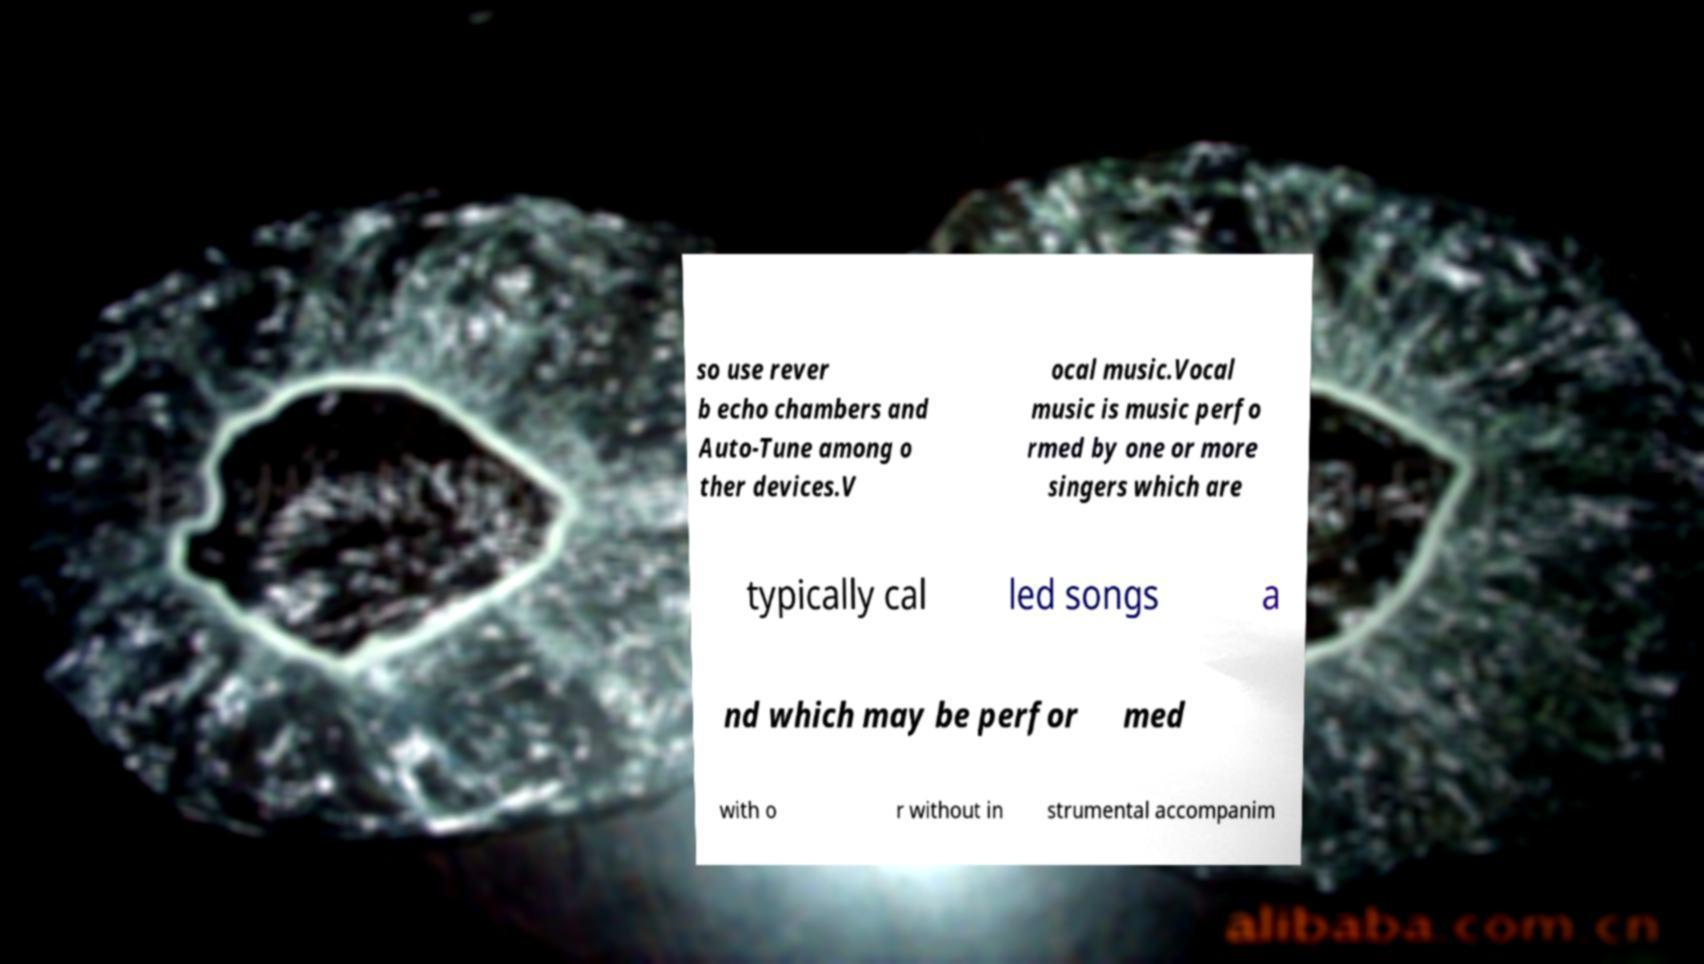There's text embedded in this image that I need extracted. Can you transcribe it verbatim? so use rever b echo chambers and Auto-Tune among o ther devices.V ocal music.Vocal music is music perfo rmed by one or more singers which are typically cal led songs a nd which may be perfor med with o r without in strumental accompanim 